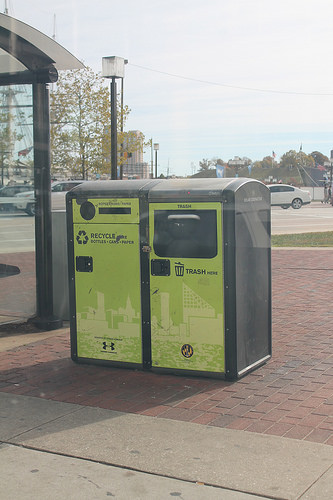<image>
Can you confirm if the waste bin is behind the street light? No. The waste bin is not behind the street light. From this viewpoint, the waste bin appears to be positioned elsewhere in the scene. 